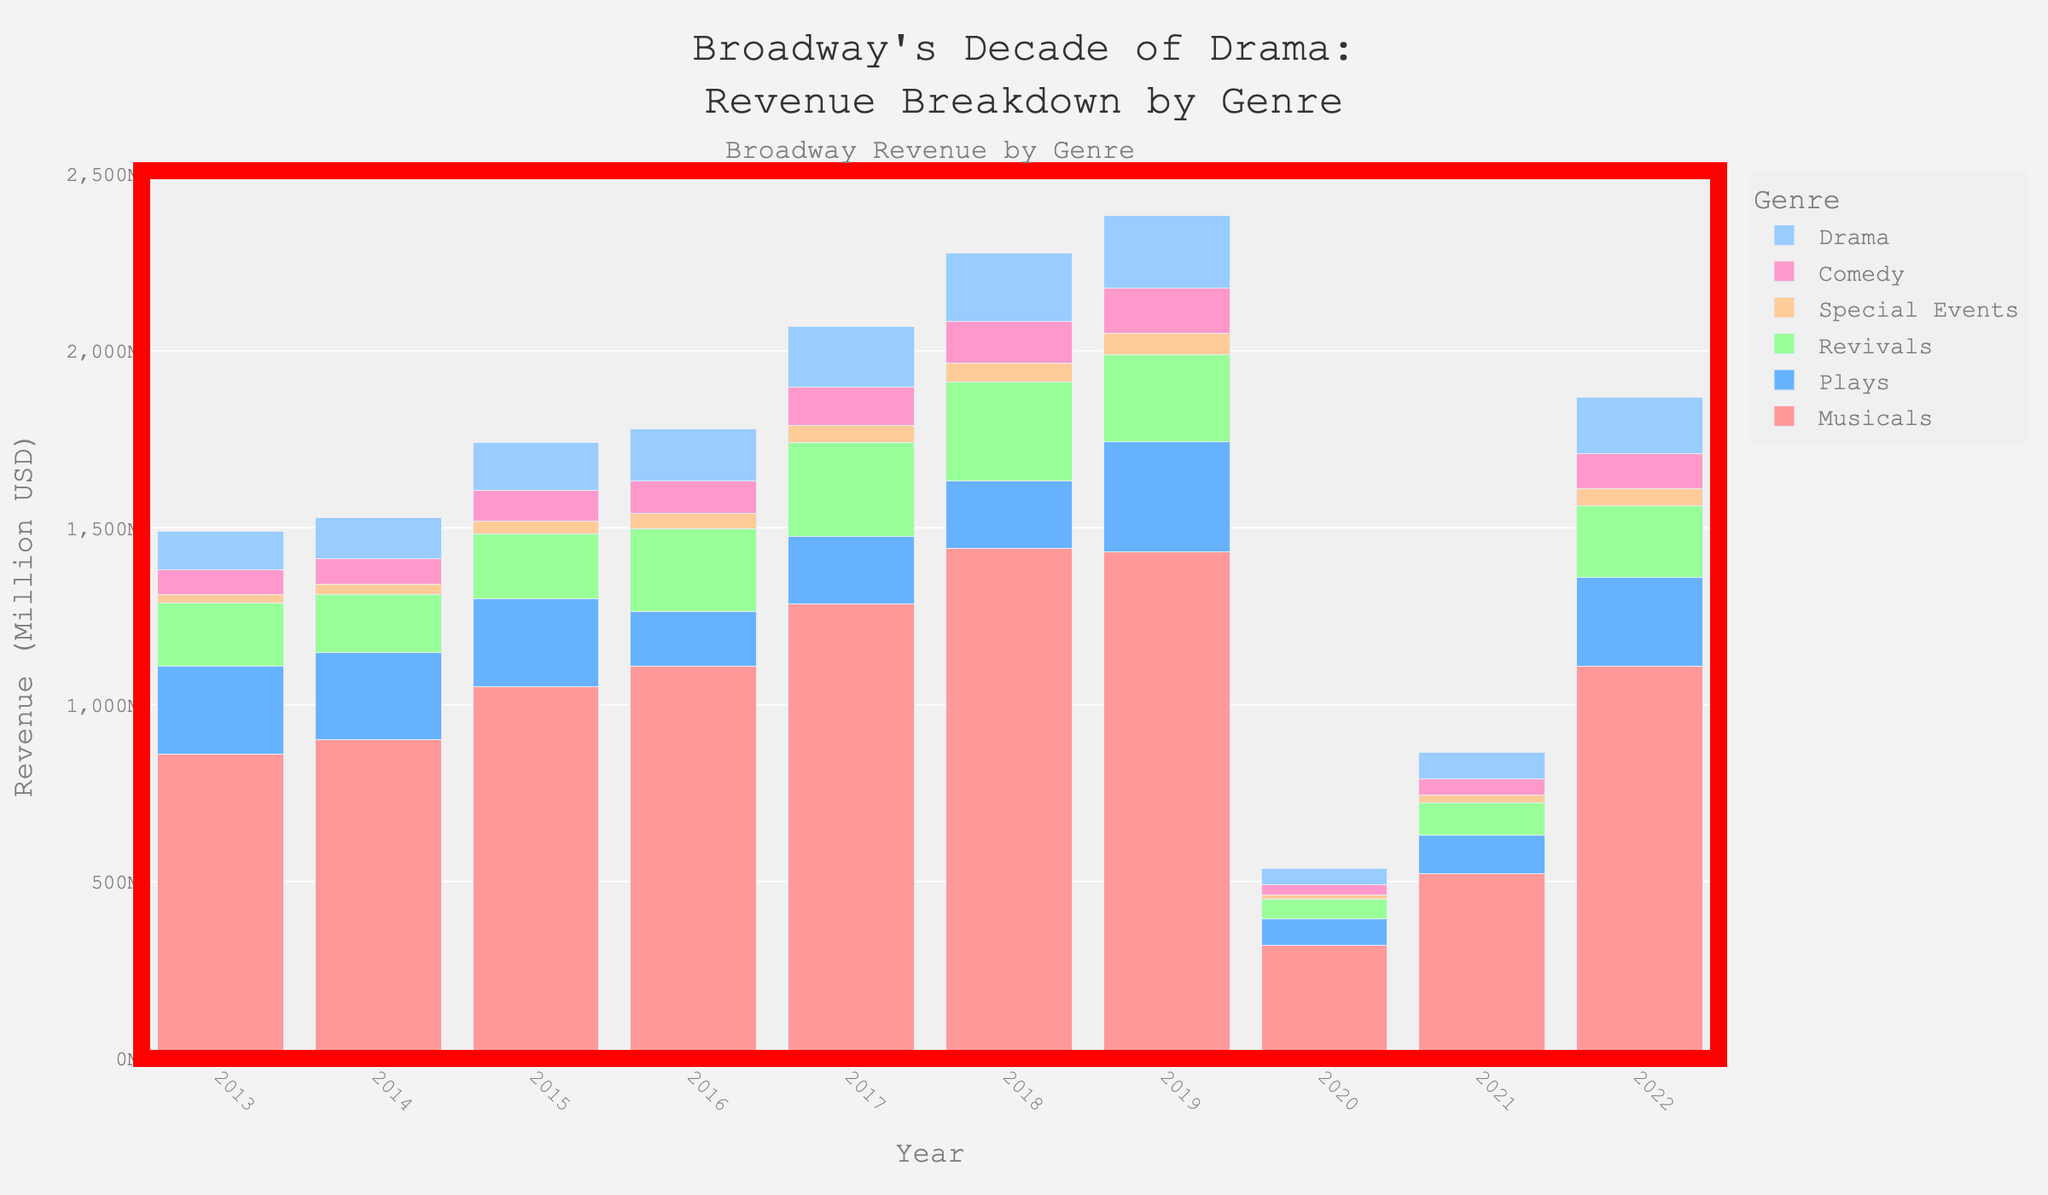Which genre experienced the highest revenue in 2022? Look at the bar heights for 2022 and identify which is the tallest bar; it represents the highest revenue.
Answer: Musicals Which year had the lowest total revenue across all genres? Sum the revenues for each year and identify the smallest sum.
Answer: 2020 How much more revenue did Musicals generate in 2018 compared to Revivals in the same year? Look at the height of the 2018 bars for Musicals and Revivals, then subtract the revenue of Revivals from Musicals.
Answer: 1161.4 million USD What is the trend in revenue for Plays from 2013 to 2022? Observe the heights of the bars representing Plays across all years and describe the pattern.
Answer: Fluctuating with significant drops in 2016 and 2020, recovery post-2020 Did Comedy or Drama generate higher revenue in 2019? Compare the heights of the 2019 bars for Comedy and Drama.
Answer: Drama Which genre saw the most significant drop in revenue from 2019 to 2020? Compare the differences in bar heights from 2019 to 2020 for all genres and identify the largest drop.
Answer: Musicals What was the average annual revenue for Special Events over the decade? Add the annual revenues for Special Events from 2013 to 2022, then divide by 10 to find the average.
Answer: 38.93 million USD In which year did Musicals contribute to more than half of the total Broadway revenue? Calculate the total revenue for each year and see if Musicals' revenue exceeds half of this total for any year.
Answer: Every year except 2020 and 2021 What is the combined revenue for Plays and Revivals in 2017? Add the revenues of Plays and Revivals for the year 2017.
Answer: 456.2 million USD Which genre achieved its maximum revenue in 2018? Compare the highest bar heights across different genres; identify which genre has its tallest bar in 2018.
Answer: Musicals 